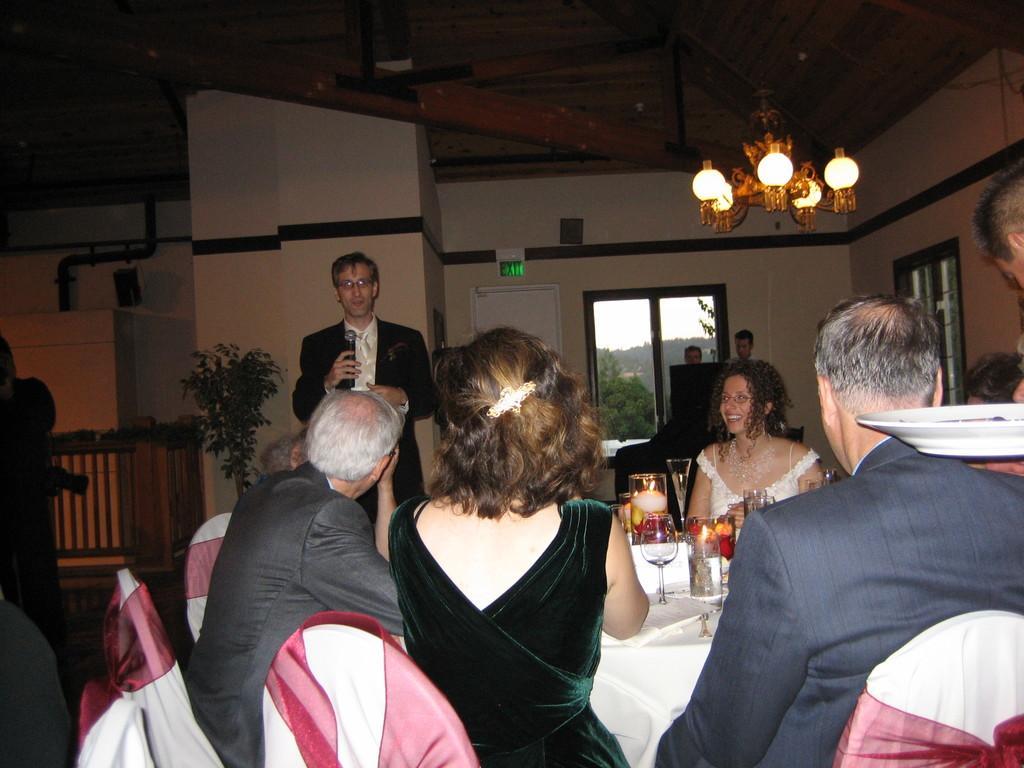Could you give a brief overview of what you see in this image? In this picture I can see group of people sitting on the chairs, there are wine glasses and some other objects on the table, there is a man standing and holding a mike, there is a chandelier and a house plant, there are iron grilles, through the window I can see trees and the sky. 